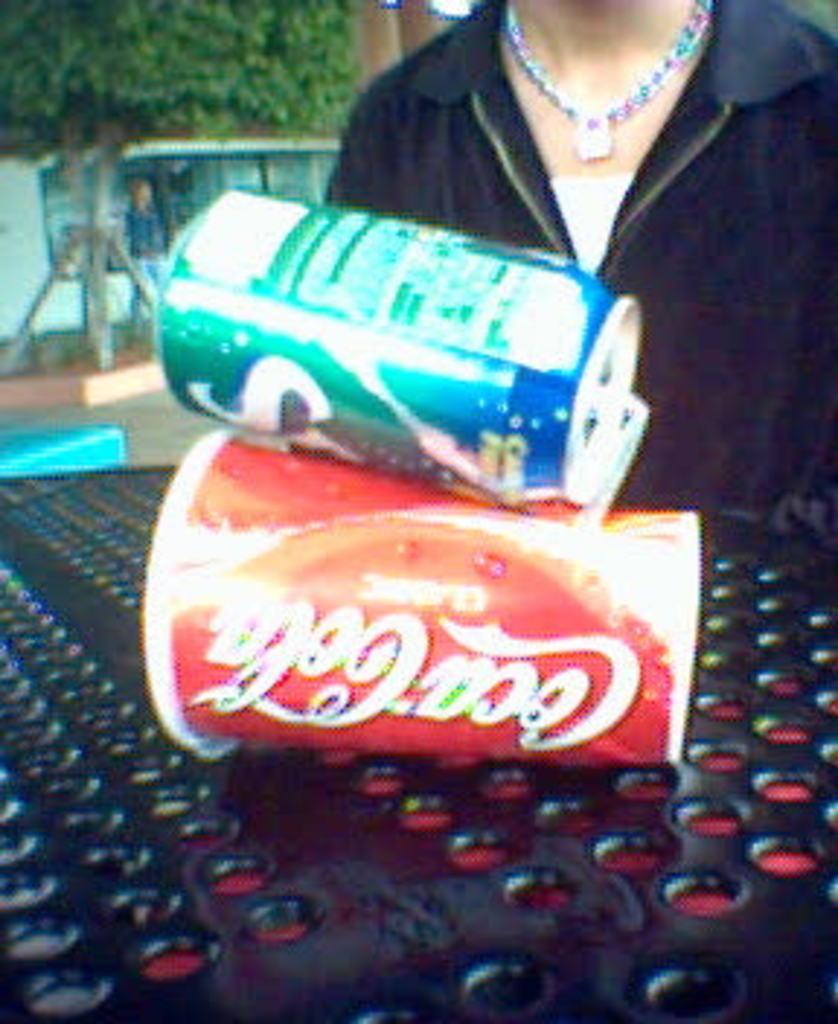Describe this image in one or two sentences. In this image I can see a person,tree,building , in front of building I can see another person visible at the top, at the bottom I can see a table with holes, contain two coke tin on it. 